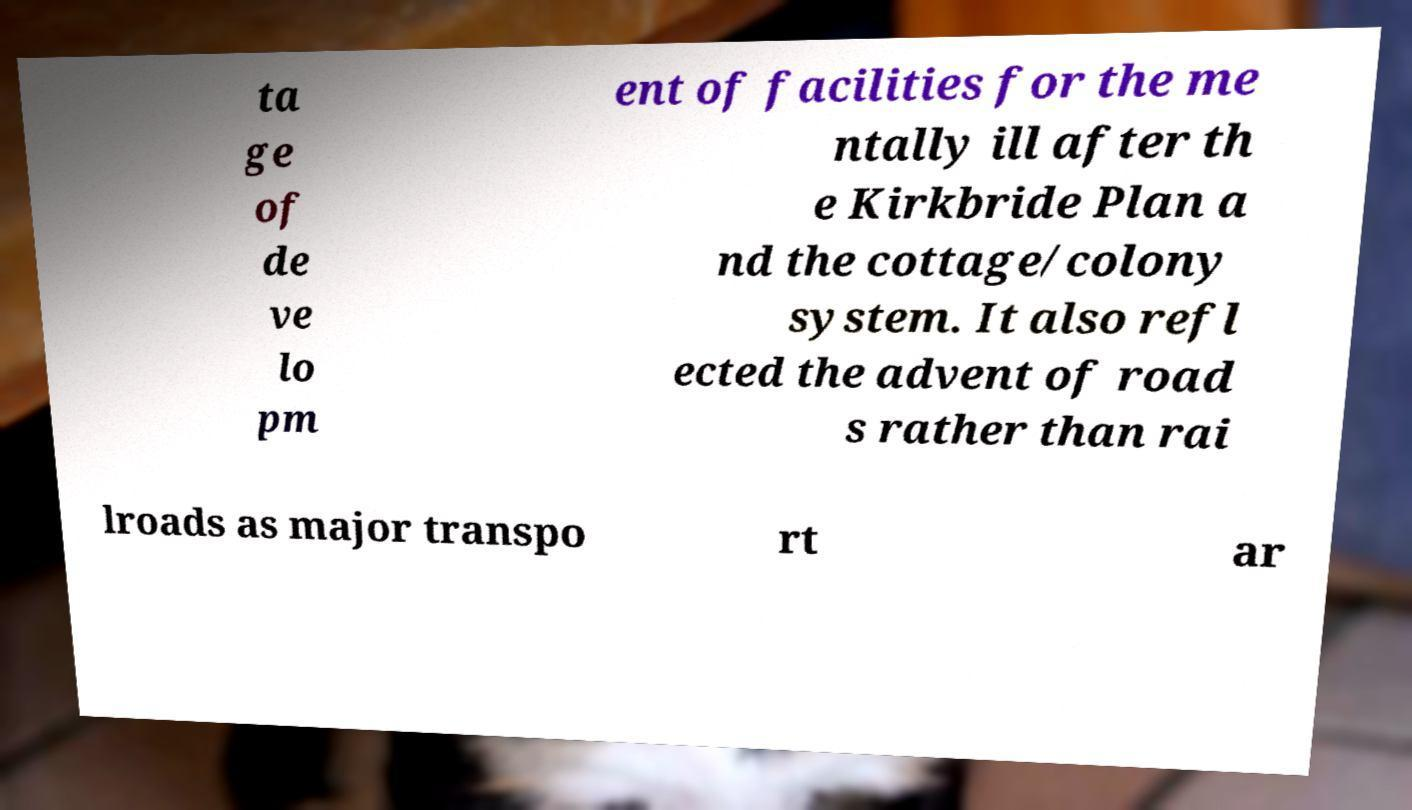Could you assist in decoding the text presented in this image and type it out clearly? ta ge of de ve lo pm ent of facilities for the me ntally ill after th e Kirkbride Plan a nd the cottage/colony system. It also refl ected the advent of road s rather than rai lroads as major transpo rt ar 